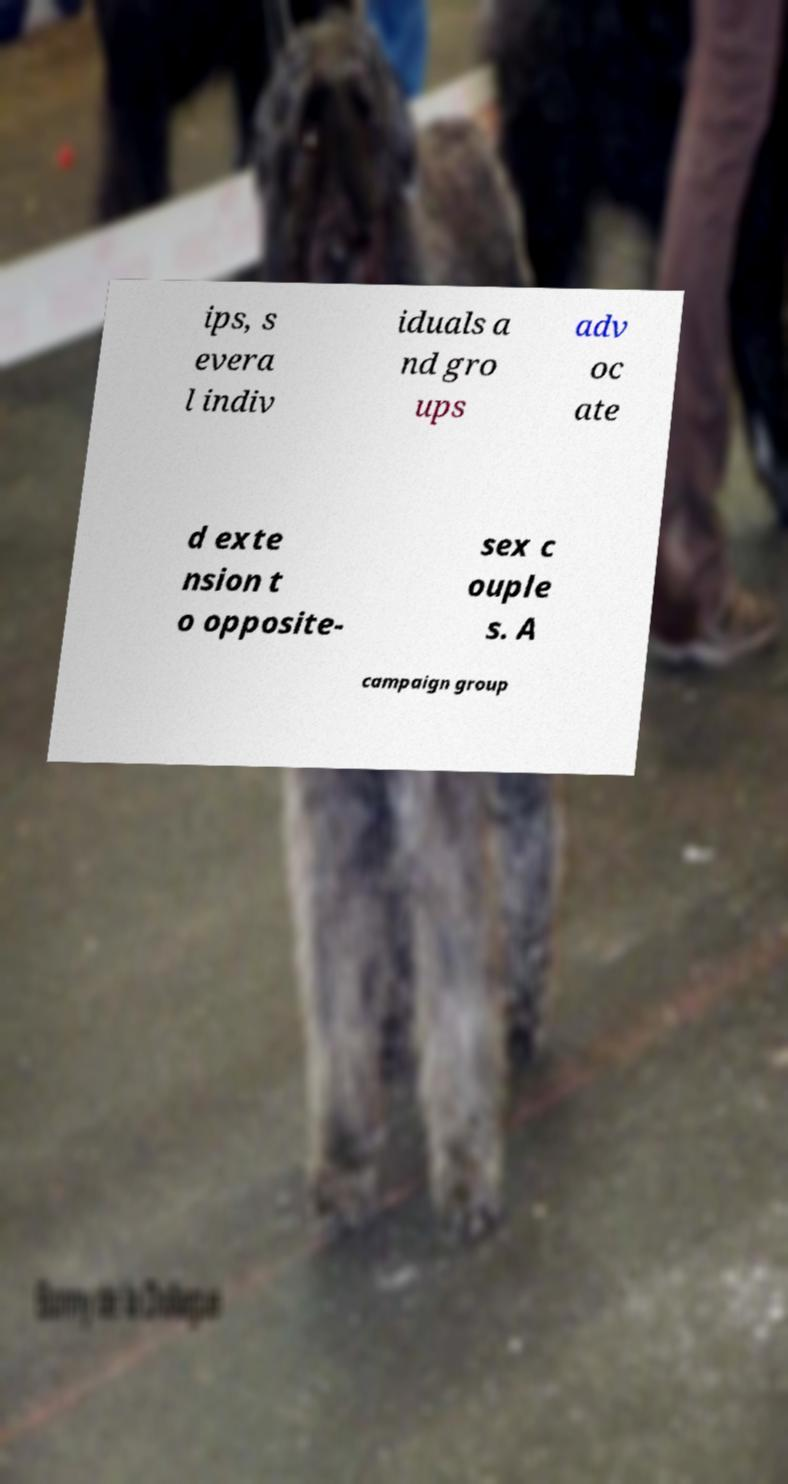There's text embedded in this image that I need extracted. Can you transcribe it verbatim? ips, s evera l indiv iduals a nd gro ups adv oc ate d exte nsion t o opposite- sex c ouple s. A campaign group 